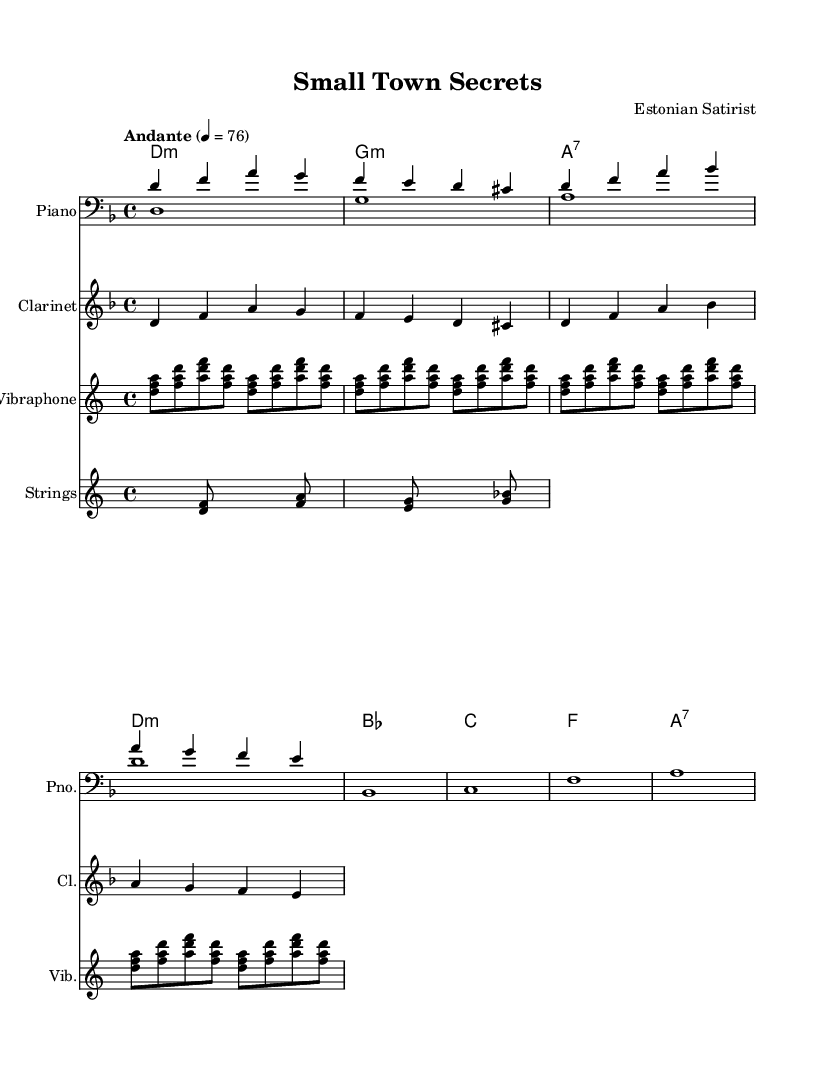What is the key signature of this music? The key signature is D minor, which is indicated by one flat (B flat).
Answer: D minor What is the time signature of this piece? The time signature is 4/4, which means there are four beats in each measure.
Answer: 4/4 What tempo marking is indicated for the piece? The tempo marking is "Andante," which suggests a moderately slow tempo.
Answer: Andante How many measures are present in the melody? The melody consists of four measures, each containing a specific sequence of notes.
Answer: 4 What instruments are featured in the score? The featured instruments in the score include Piano, Clarinet, Vibraphone, and Strings, clearly labeled.
Answer: Piano, Clarinet, Vibraphone, Strings Which chord changes occur in the first two measures of the harmony? The first two measures feature a D minor chord followed by G minor, indicating the harmonic progression.
Answer: D minor, G minor 